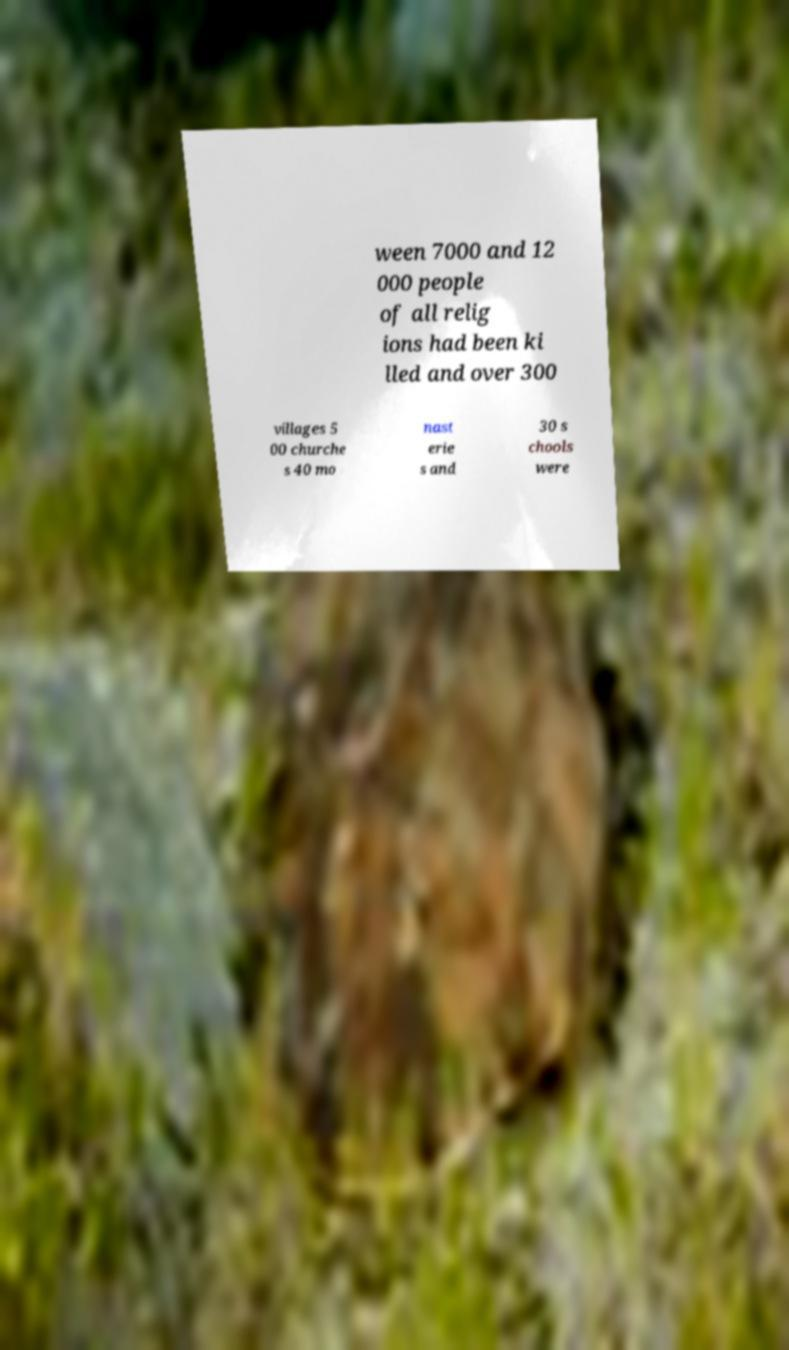There's text embedded in this image that I need extracted. Can you transcribe it verbatim? ween 7000 and 12 000 people of all relig ions had been ki lled and over 300 villages 5 00 churche s 40 mo nast erie s and 30 s chools were 